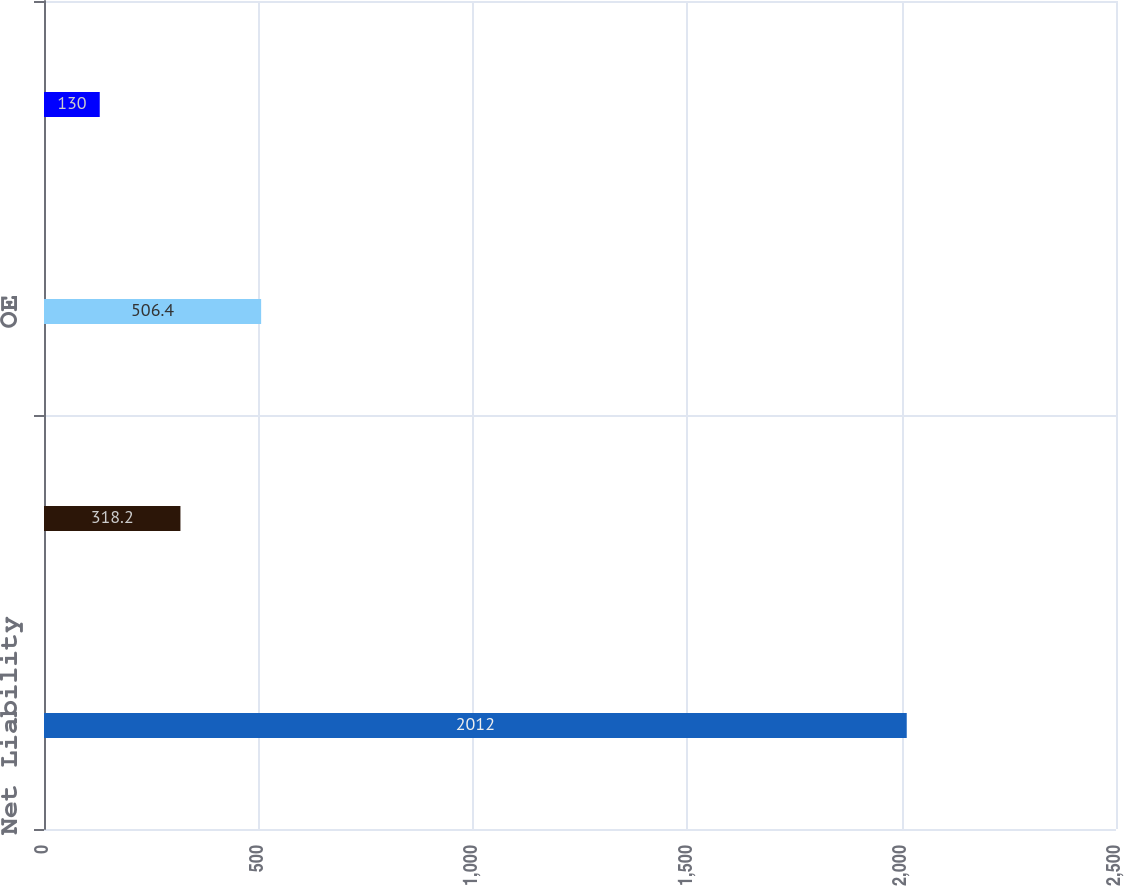Convert chart. <chart><loc_0><loc_0><loc_500><loc_500><bar_chart><fcel>Net Liability<fcel>FES<fcel>OE<fcel>JCP&L<nl><fcel>2012<fcel>318.2<fcel>506.4<fcel>130<nl></chart> 